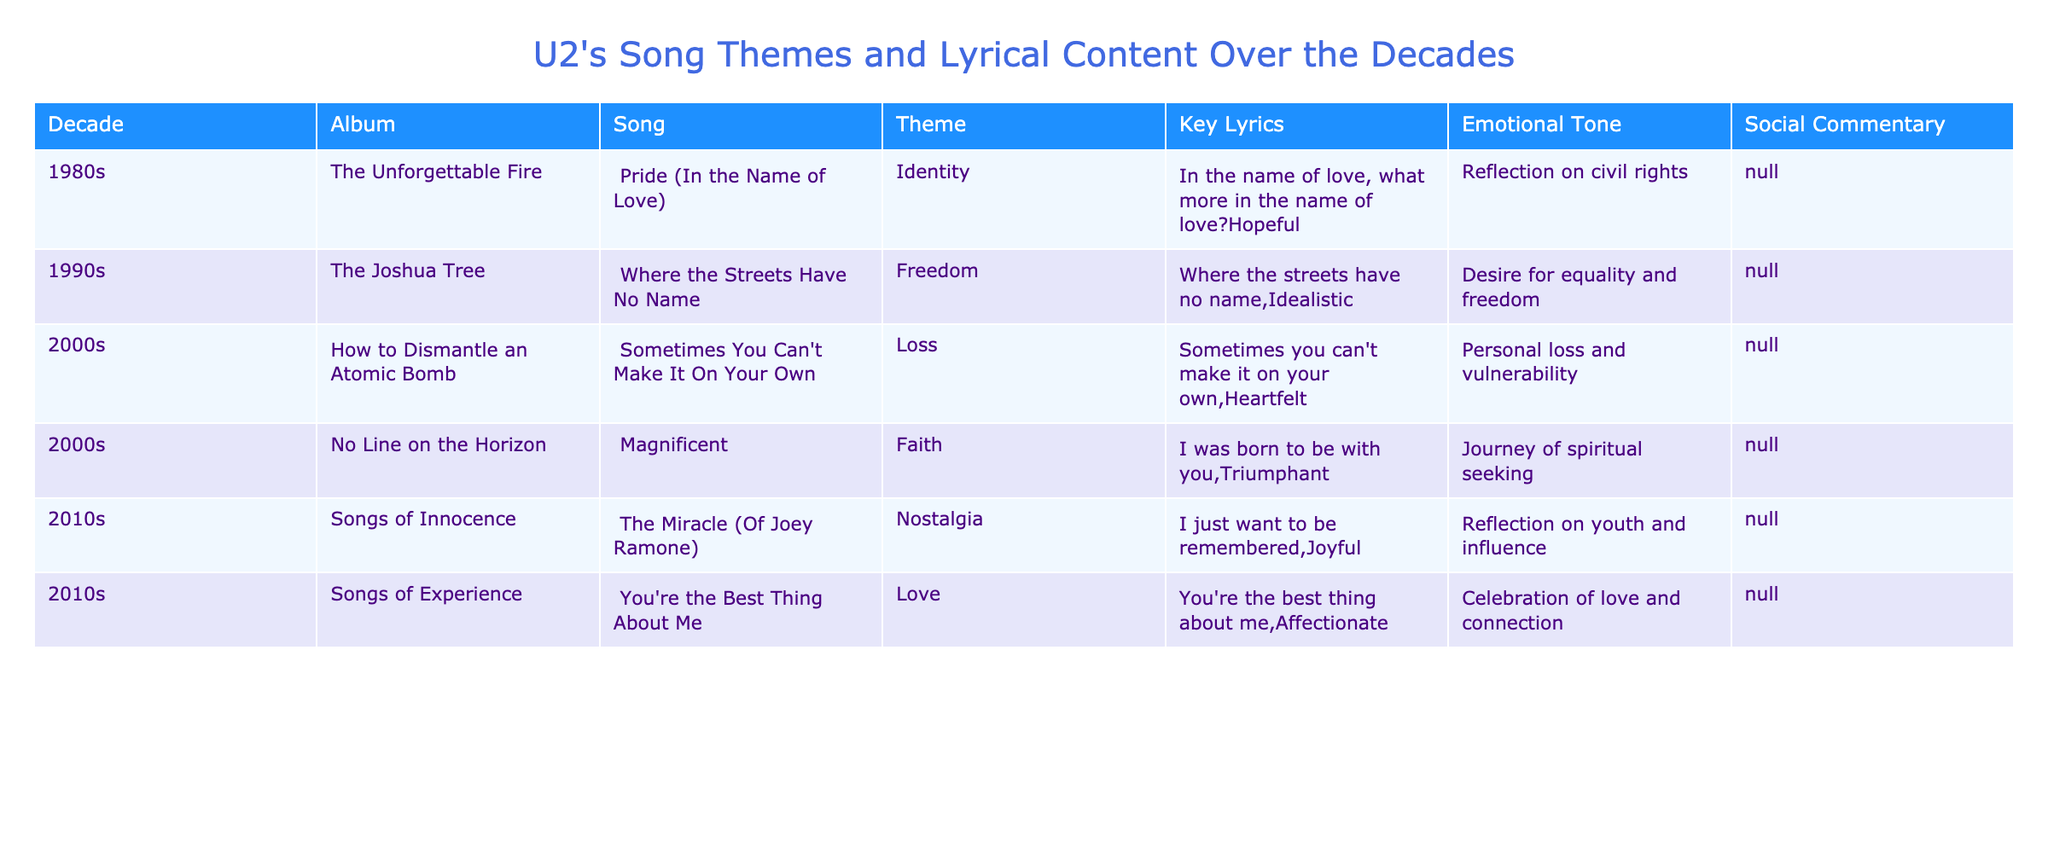What is the theme of the song "Pride (In the Name of Love)"? By referring to the table under the song title "Pride (In the Name of Love)", I can see that the theme listed is "Identity".
Answer: Identity Which decade features the song "The Miracle (Of Joey Ramone"? Looking at the table, the decade corresponding to "The Miracle (Of Joey Ramone)" is the 2010s.
Answer: 2010s How many songs listed have a theme of Love? By counting the rows in the table, "You're the Best Thing About Me" is the only song with the theme of Love. Thus, there is 1 song with this theme.
Answer: 1 Is "Sometimes You Can't Make It On Your Own" characterized as hopeful? According to the table, the emotional tone of "Sometimes You Can't Make It On Your Own" is described as heartfelt, not hopeful. Therefore, the answer is no.
Answer: No What was the emotional tone of the song "Magnificent"? From the table, I can see that the emotional tone for "Magnificent" is classified as triumphant.
Answer: Triumphant What is the most common theme found in U2's songs from the provided data? Analyzing the themes in the table, "Nostalgia" appears only once, and "Loss" and "Love" appear once each. The most frequent theme is "Identity" and "Freedom," both occurring once, which means there is no clear common theme.
Answer: None Which song reflects a journey of spiritual seeking? By reviewing the table, I can conclude that the song "Magnificent" reflects a journey of spiritual seeking.
Answer: Magnificent How does the lyrical content of "Where the Streets Have No Name" comment on society? The table indicates that "Where the Streets Have No Name" provides a social commentary on the "Desire for equality and freedom".
Answer: Desire for equality and freedom How many emotional tones are represented in the songs from the data provided? By inspecting the emotional tones of each song listed, I find "Hopeful," "Idealistic," "Heartfelt," "Triumphant," "Joyful," "Affectionate," thus totaling 6 unique emotional tones.
Answer: 6 What is the key lyric from the song "You're the Best Thing About Me"? The lyrics for "You're the Best Thing About Me" as per the table are "You're the best thing about me".
Answer: You're the best thing about me 